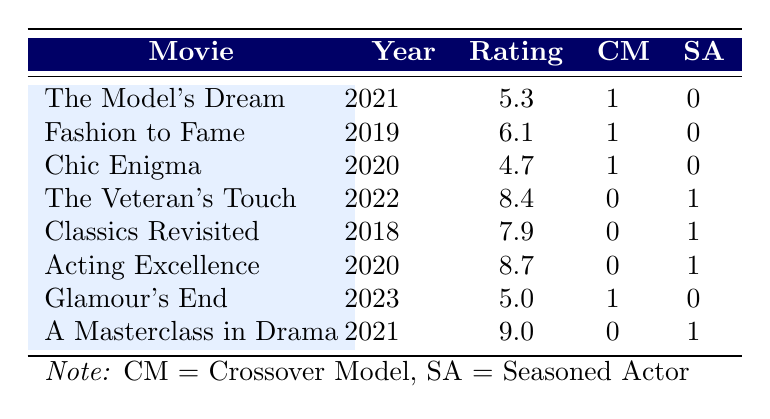What is the viewer rating for "Glamour's End"? The rating for "Glamour's End" is directly found in the table in the viewer rating column corresponding to that title, which shows 5.0.
Answer: 5.0 What is the highest viewer rating among the crossover model movies? The crossover model movies are "The Model's Dream," "Fashion to Fame," "Chic Enigma," and "Glamour's End." Their ratings are 5.3, 6.1, 4.7, and 5.0, respectively. The highest of these ratings is 6.1 for "Fashion to Fame."
Answer: 6.1 Is "Acting Excellence" rated higher than "The Model's Dream"? Comparing the viewer ratings from the table, "Acting Excellence" has a rating of 8.7, while "The Model's Dream" has a rating of 5.3. Since 8.7 is greater than 5.3, "Acting Excellence" is indeed rated higher.
Answer: Yes What is the average viewer rating for movies featuring seasoned actors? The ratings for movies with seasoned actors are 8.4, 7.9, 8.7, and 9.0. Adding these ratings gives a total of 34.0. There are 4 movies in this group, so the average is 34.0 divided by 4, which equals 8.5.
Answer: 8.5 How many movies featuring crossover models have ratings below 6.0? The crossover model movies and their ratings are 5.3, 6.1, 4.7, and 5.0. The ratings below 6.0 are 5.3, 4.7, and 5.0, giving us a total of 3 movies.
Answer: 3 What is the difference between the highest-rated movie featuring a seasoned actor and the highest-rated movie featuring a crossover model? The highest-rated movie featuring a seasoned actor is "A Masterclass in Drama," with a rating of 9.0. The highest-rated movie featuring a crossover model is "Fashion to Fame," with a rating of 6.1. The difference is 9.0 - 6.1 = 2.9.
Answer: 2.9 Is there any crossover model movie with a rating higher than 7.0? After reviewing the ratings of the crossover model movies (5.3, 6.1, 4.7, and 5.0), none of these ratings exceed 7.0, it is clear that no crossover model movie meets this criterion.
Answer: No Which actor type has the overall higher average viewer rating? The average viewer ratings were calculated separately: for seasoned actors, the average rating is 8.5; for crossover models, the average is (5.3 + 6.1 + 4.7 + 5.0) which equals 21.1 / 4 = 5.275. Therefore, seasoned actors have the higher average rating.
Answer: Seasoned Actor 